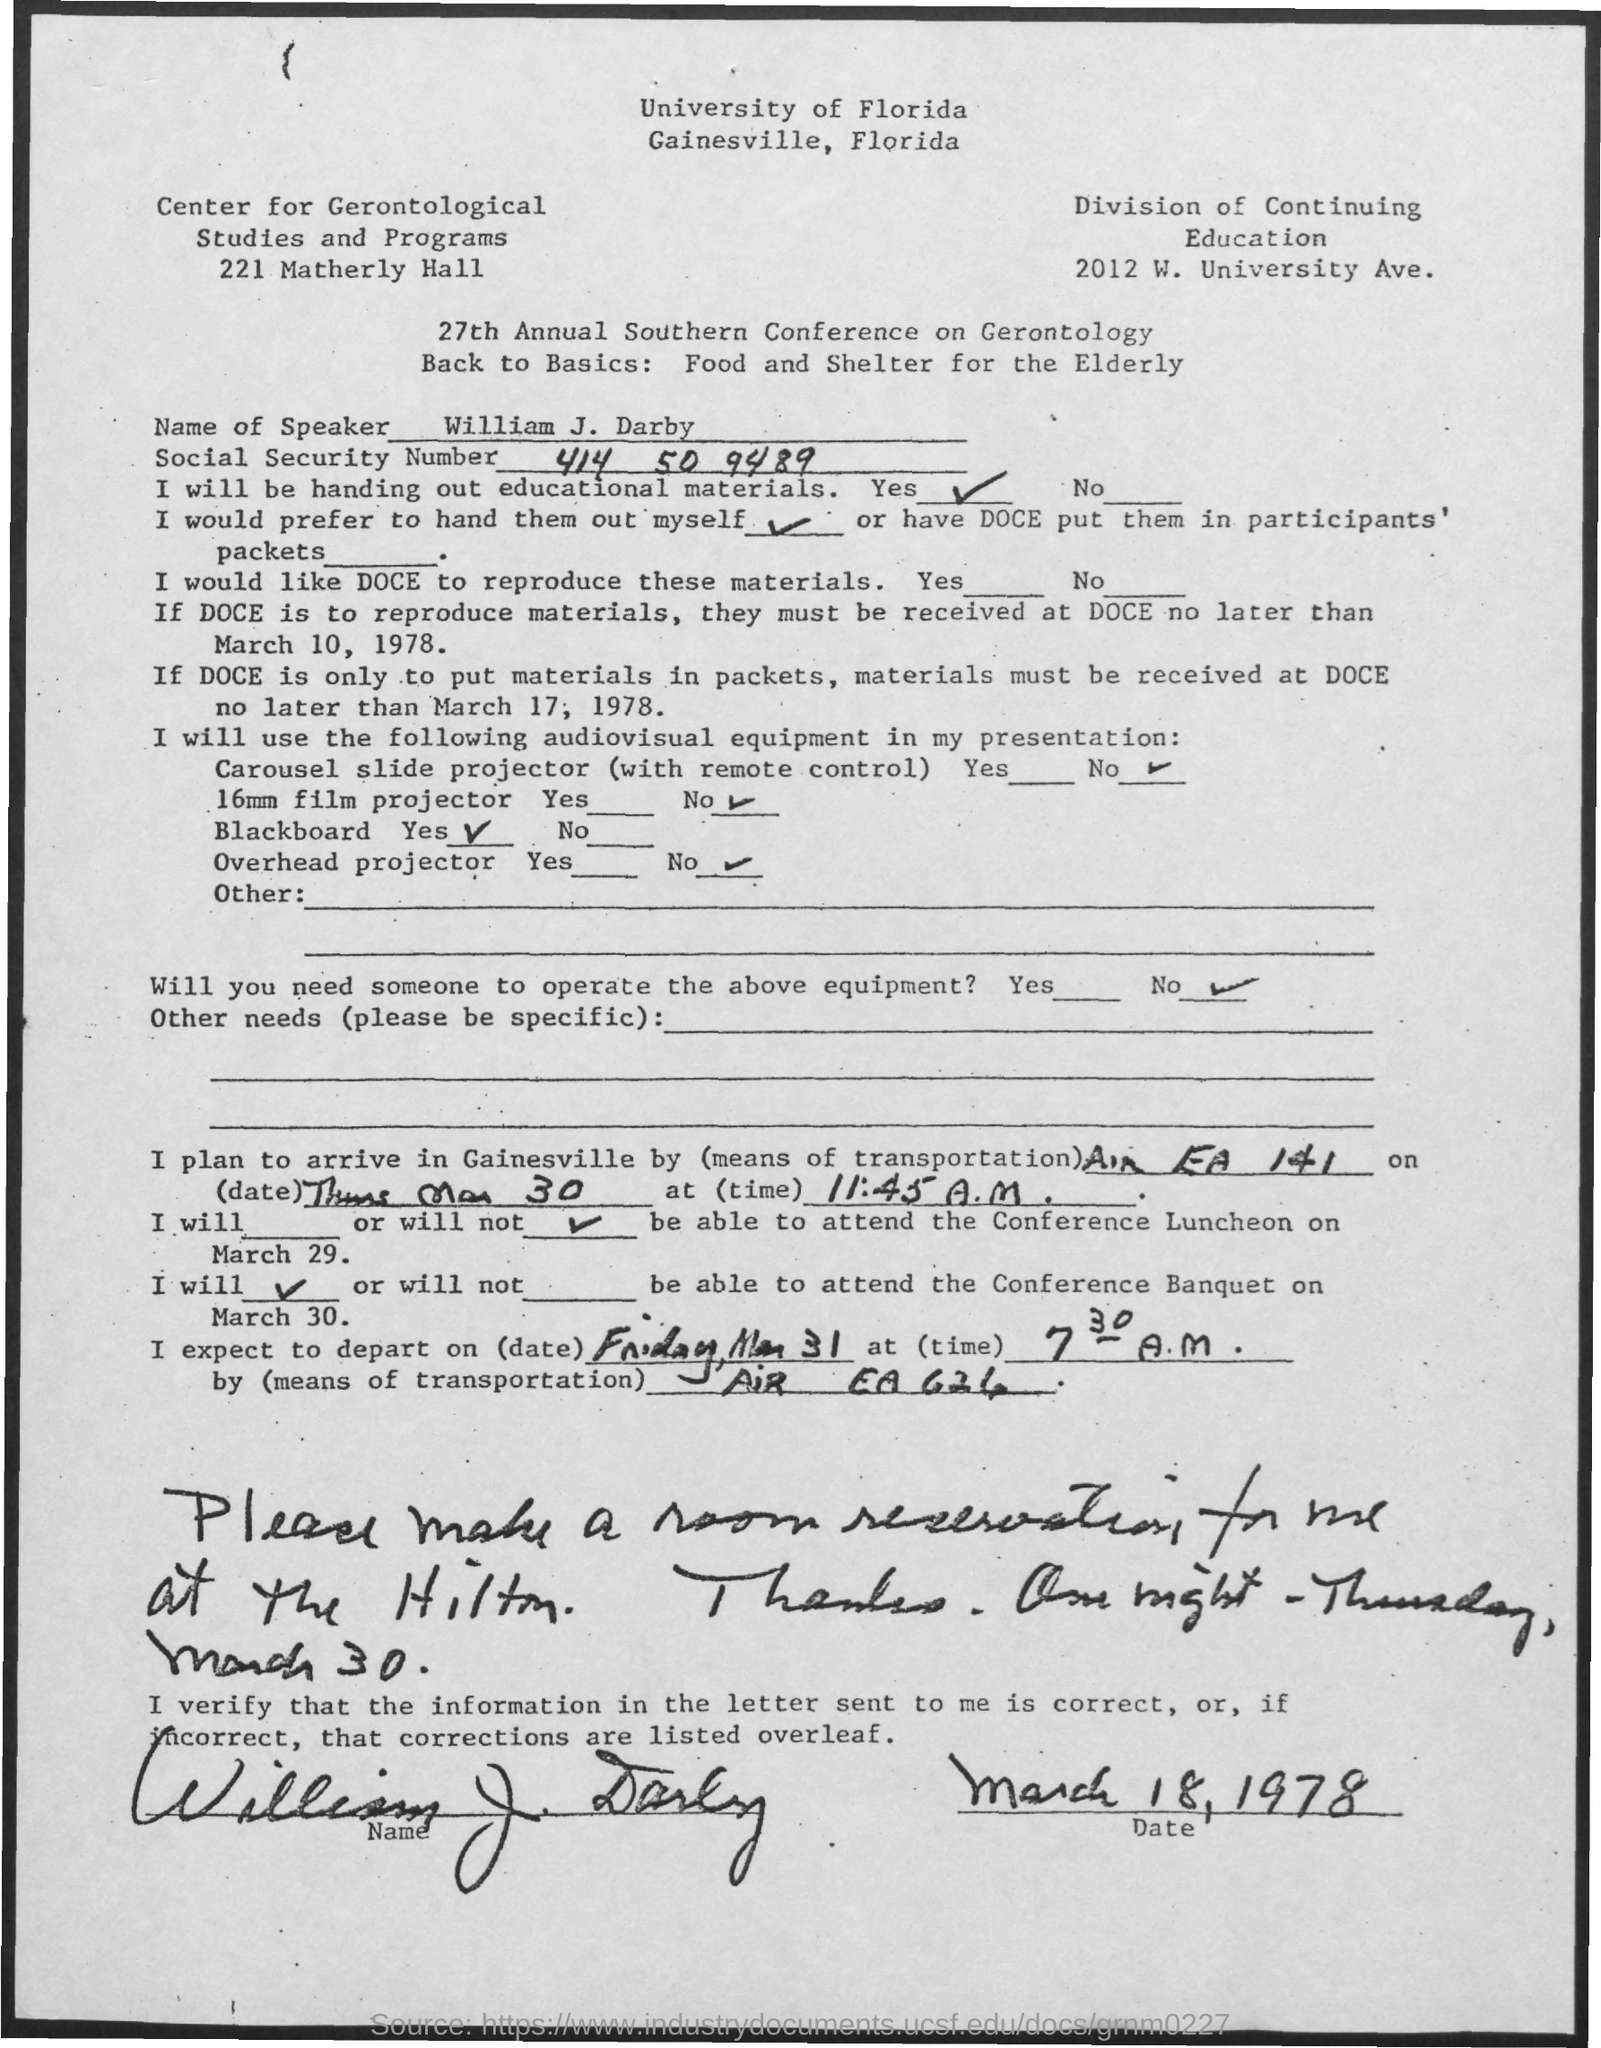What is the Social Security Number?
Provide a succinct answer. 414 50 9489. 